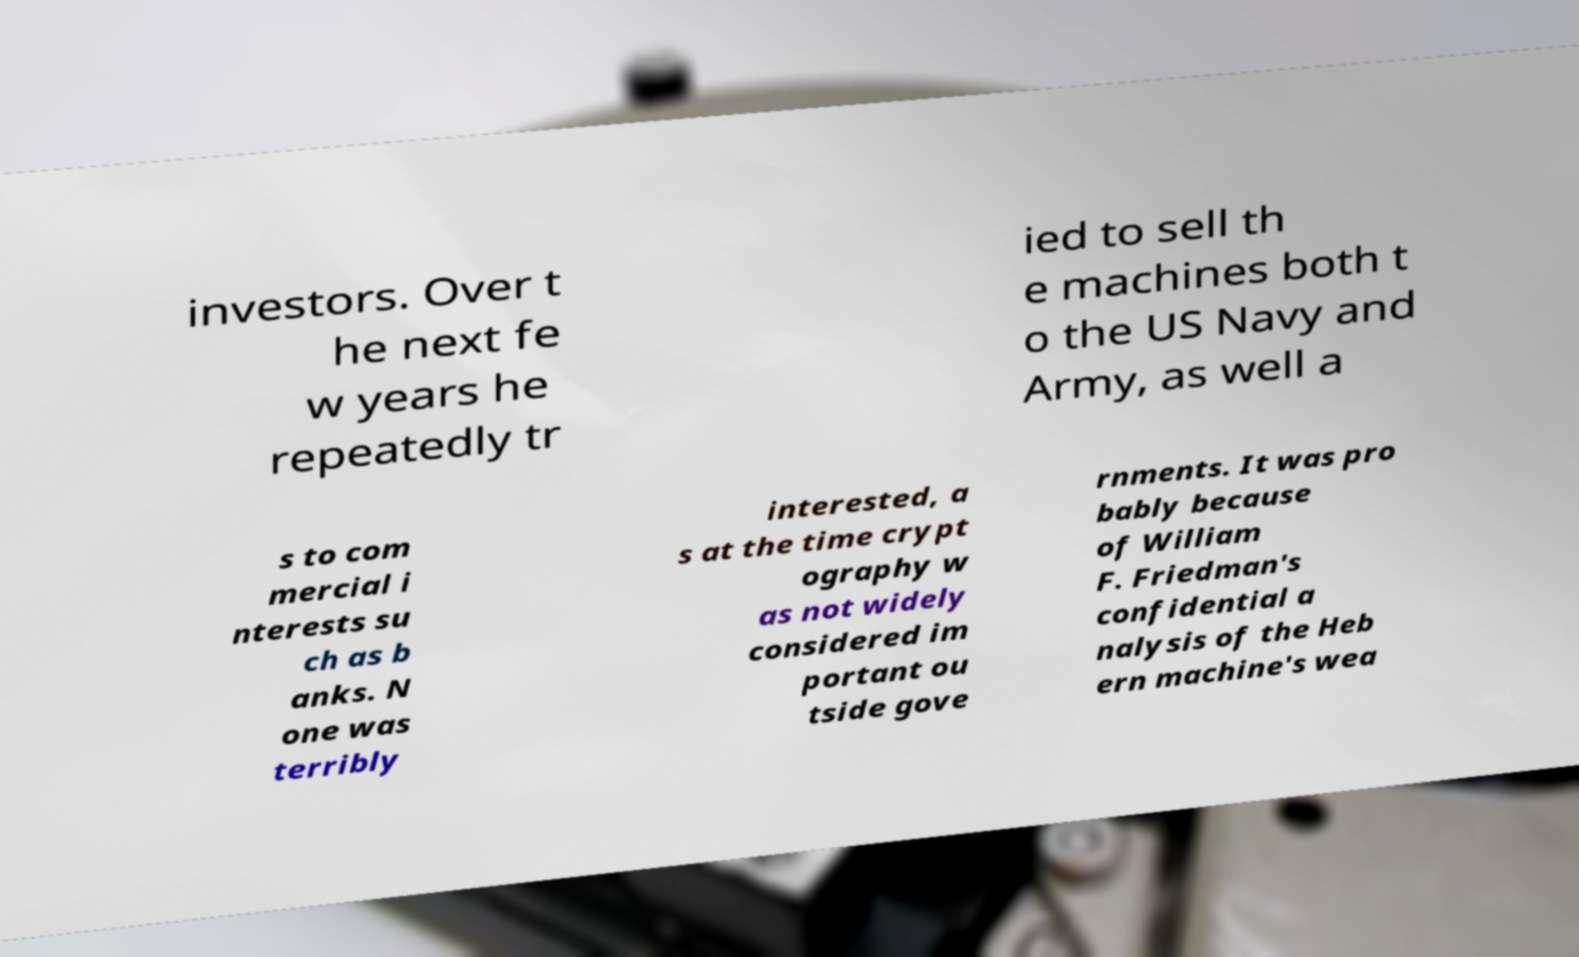What messages or text are displayed in this image? I need them in a readable, typed format. investors. Over t he next fe w years he repeatedly tr ied to sell th e machines both t o the US Navy and Army, as well a s to com mercial i nterests su ch as b anks. N one was terribly interested, a s at the time crypt ography w as not widely considered im portant ou tside gove rnments. It was pro bably because of William F. Friedman's confidential a nalysis of the Heb ern machine's wea 